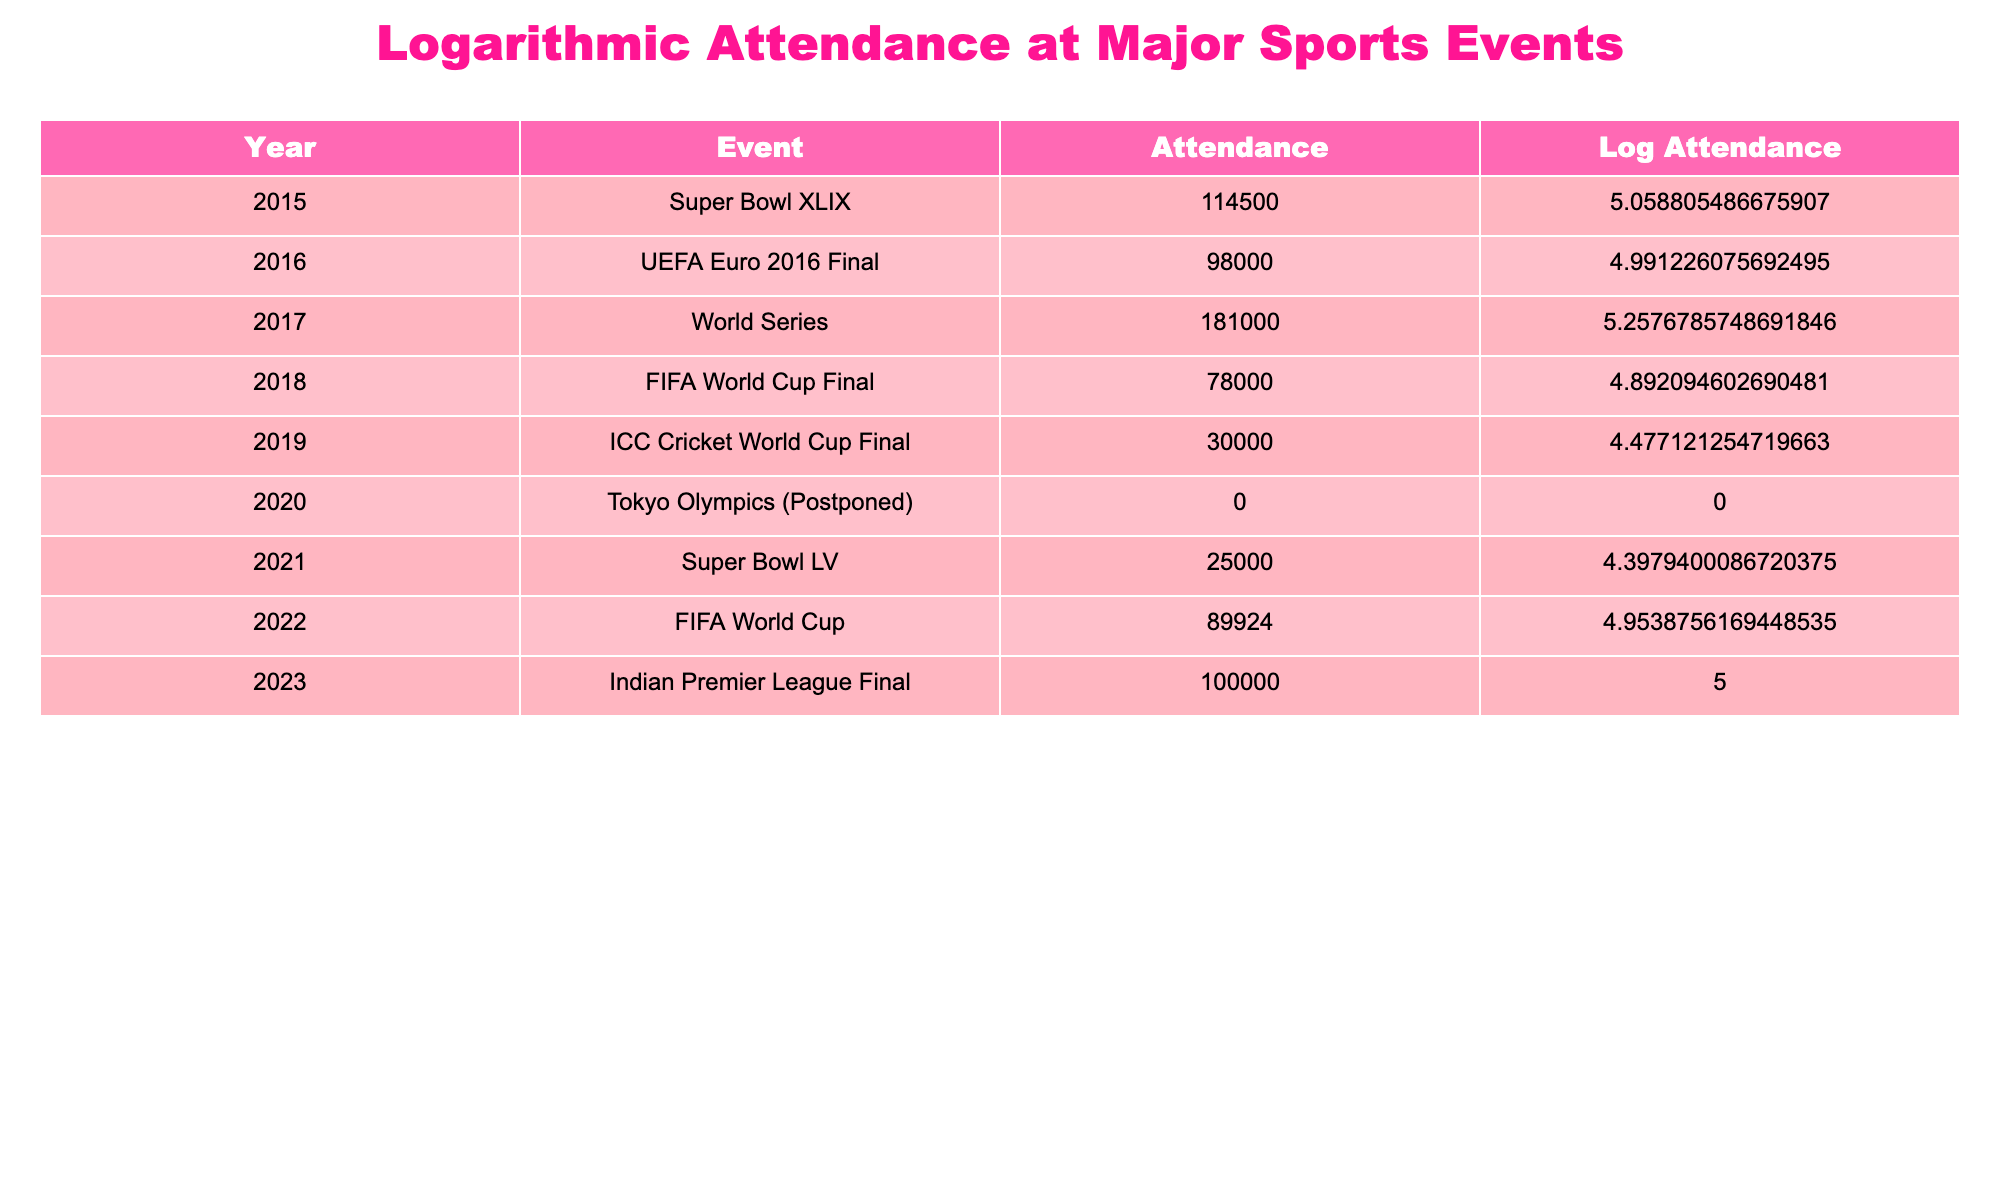What was the attendance at the FIFA World Cup Final in 2018? The table lists the year and the corresponding event along with their attendance figures. For the FIFA World Cup Final, which took place in 2018, the attendance is explicitly mentioned as 78,000.
Answer: 78,000 Which event had the highest attendance? To identify which event had the highest attendance, we can compare the attendance figures provided for each event. Upon reviewing the figures, the World Series in 2017 had the highest attendance at 181,000.
Answer: World Series in 2017 Is it true that the attendance at the Tokyo Olympics (Postponed) was zero? The table shows that for the Tokyo Olympics in the year 2020, the attendance recorded is 0. Thus, the statement that attendance was zero is true based on the information given in the table.
Answer: Yes What is the average attendance for events listed from 2015 to 2019? To find the average attendance, we first sum up the attendance figures for those years: 114,500 + 98,000 + 181,000 + 78,000 + 30,000 = 501,500. There are 5 events in this range, so we divide the total by 5, which gives us an average of 100,300.
Answer: 100,300 Did the attendance increase or decrease from the Super Bowl in 2015 to Super Bowl LV in 2021? In 2015, the Super Bowl XLIX had an attendance of 114,500 and in 2021, the Super Bowl LV had an attendance of 25,000. By comparing the two figures, we see that attendance decreased from 114,500 to 25,000, leading to a significant drop.
Answer: Decrease What is the difference in attendance between the UEFA Euro 2016 Final and the FIFA World Cup in 2022? The attendance at the UEFA Euro 2016 Final is 98,000 and for the FIFA World Cup in 2022, it is 89,924. We subtract the latter from the former: 98,000 - 89,924 = 8,076.
Answer: 8,076 What is the attendance at the Indian Premier League Final in 2023 compared to the average attendance of preceding events? The attendance at the Indian Premier League Final in 2023 is 100,000. The average attendance of preceding events (from 2015 to 2022 calculated previously) is 100,300. Thus, when comparing, 100,000 is slightly less than 100,300.
Answer: Less Which year had no recorded attendance, and what event did that pertain to? The table shows that for the year 2020, the recorded attendance is 0, which corresponds to the Tokyo Olympics that were postponed. Therefore, the year with no recorded attendance is 2020 related to the Tokyo Olympics.
Answer: 2020, Tokyo Olympics 